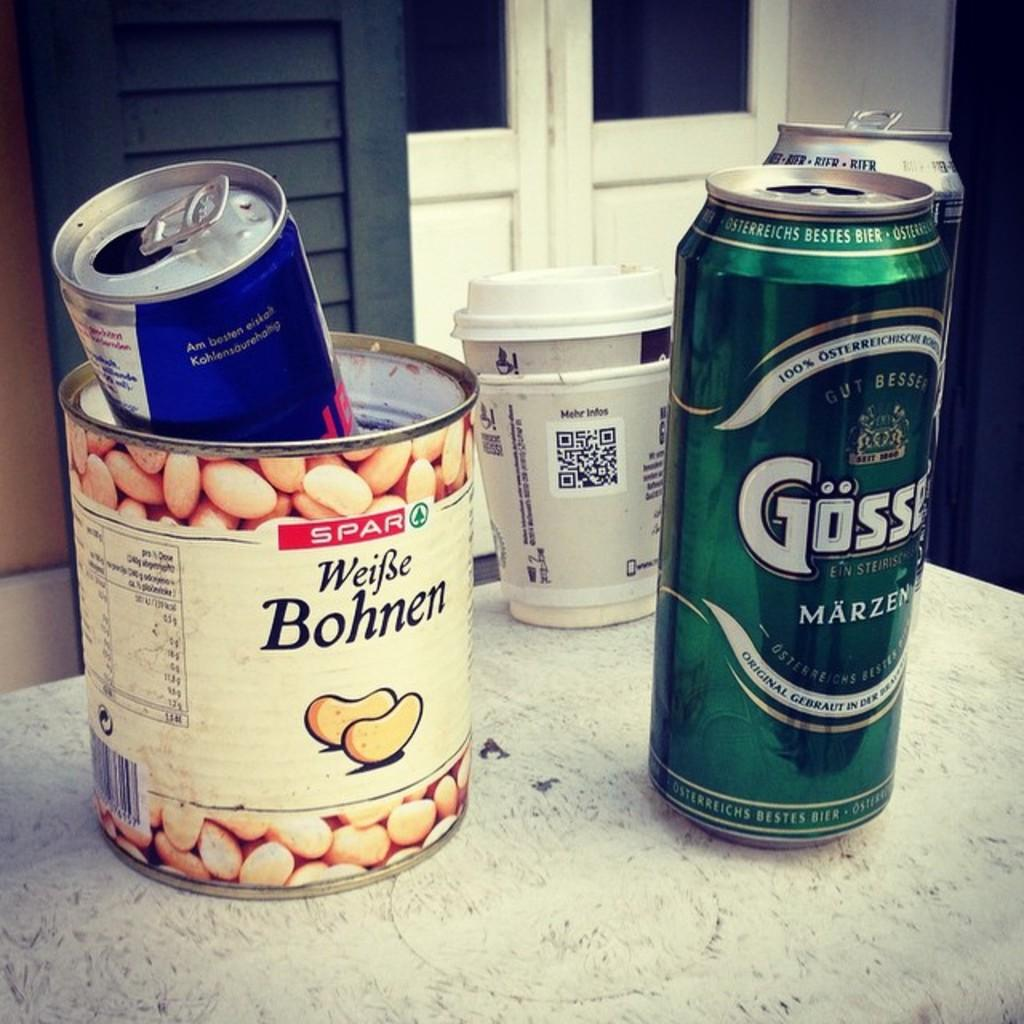Provide a one-sentence caption for the provided image. White beans were once contained in this tin can but it now holds a red bull can. 